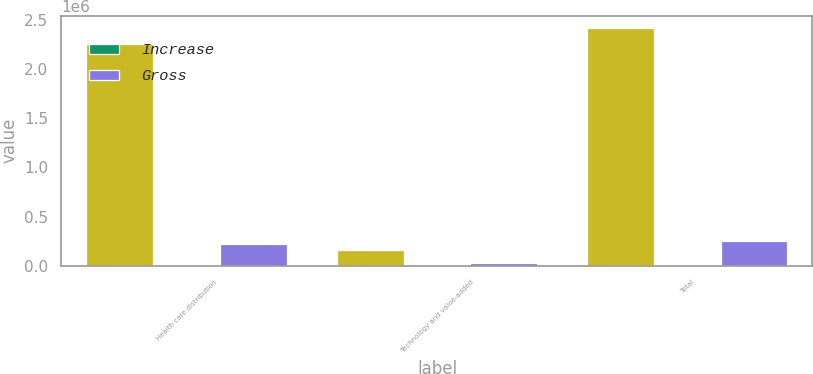Convert chart to OTSL. <chart><loc_0><loc_0><loc_500><loc_500><stacked_bar_chart><ecel><fcel>Health care distribution<fcel>Technology and value-added<fcel>Total<nl><fcel>nan<fcel>2.25381e+06<fcel>164241<fcel>2.41806e+06<nl><fcel>Increase<fcel>27.2<fcel>65.5<fcel>28.3<nl><fcel>Gross<fcel>219954<fcel>27225<fcel>247179<nl></chart> 